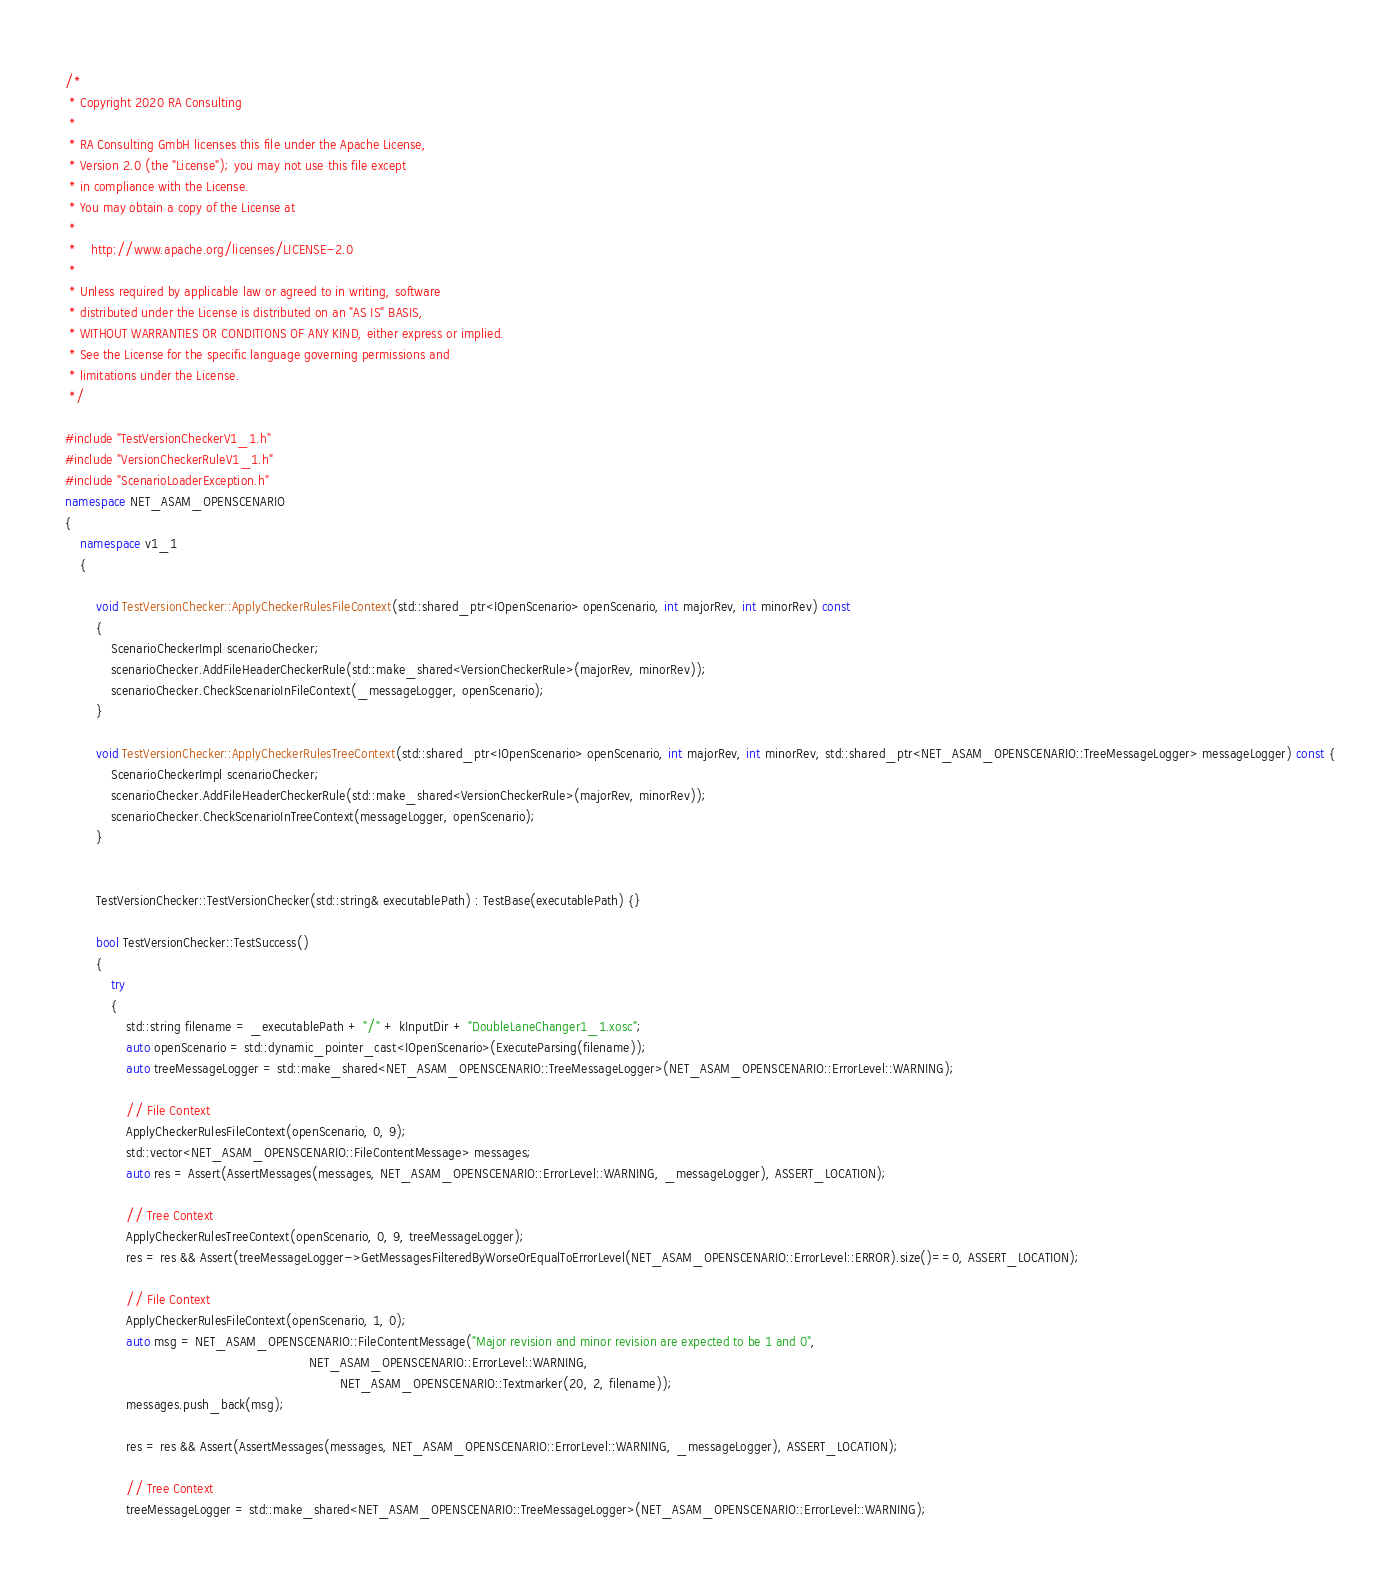<code> <loc_0><loc_0><loc_500><loc_500><_C++_>/*
 * Copyright 2020 RA Consulting
 *
 * RA Consulting GmbH licenses this file under the Apache License,
 * Version 2.0 (the "License"); you may not use this file except
 * in compliance with the License.
 * You may obtain a copy of the License at
 *
 *    http://www.apache.org/licenses/LICENSE-2.0
 *
 * Unless required by applicable law or agreed to in writing, software
 * distributed under the License is distributed on an "AS IS" BASIS,
 * WITHOUT WARRANTIES OR CONDITIONS OF ANY KIND, either express or implied.
 * See the License for the specific language governing permissions and
 * limitations under the License.
 */

#include "TestVersionCheckerV1_1.h"
#include "VersionCheckerRuleV1_1.h"
#include "ScenarioLoaderException.h"
namespace NET_ASAM_OPENSCENARIO
{
    namespace v1_1
	{

		void TestVersionChecker::ApplyCheckerRulesFileContext(std::shared_ptr<IOpenScenario> openScenario, int majorRev, int minorRev) const
		{
			ScenarioCheckerImpl scenarioChecker;
			scenarioChecker.AddFileHeaderCheckerRule(std::make_shared<VersionCheckerRule>(majorRev, minorRev));
			scenarioChecker.CheckScenarioInFileContext(_messageLogger, openScenario);
		}

		void TestVersionChecker::ApplyCheckerRulesTreeContext(std::shared_ptr<IOpenScenario> openScenario, int majorRev, int minorRev, std::shared_ptr<NET_ASAM_OPENSCENARIO::TreeMessageLogger> messageLogger) const {
			ScenarioCheckerImpl scenarioChecker;
			scenarioChecker.AddFileHeaderCheckerRule(std::make_shared<VersionCheckerRule>(majorRev, minorRev));
			scenarioChecker.CheckScenarioInTreeContext(messageLogger, openScenario);
		}


		TestVersionChecker::TestVersionChecker(std::string& executablePath) : TestBase(executablePath) {}

		bool TestVersionChecker::TestSuccess()
		{
			try 
			{
				std::string filename = _executablePath + "/" + kInputDir + "DoubleLaneChanger1_1.xosc";
				auto openScenario = std::dynamic_pointer_cast<IOpenScenario>(ExecuteParsing(filename));
				auto treeMessageLogger = std::make_shared<NET_ASAM_OPENSCENARIO::TreeMessageLogger>(NET_ASAM_OPENSCENARIO::ErrorLevel::WARNING);

				// File Context
				ApplyCheckerRulesFileContext(openScenario, 0, 9);
				std::vector<NET_ASAM_OPENSCENARIO::FileContentMessage> messages;
				auto res = Assert(AssertMessages(messages, NET_ASAM_OPENSCENARIO::ErrorLevel::WARNING, _messageLogger), ASSERT_LOCATION);

				// Tree Context
				ApplyCheckerRulesTreeContext(openScenario, 0, 9, treeMessageLogger);
				res = res && Assert(treeMessageLogger->GetMessagesFilteredByWorseOrEqualToErrorLevel(NET_ASAM_OPENSCENARIO::ErrorLevel::ERROR).size()==0, ASSERT_LOCATION);

				// File Context
				ApplyCheckerRulesFileContext(openScenario, 1, 0);
				auto msg = NET_ASAM_OPENSCENARIO::FileContentMessage("Major revision and minor revision are expected to be 1 and 0",
																NET_ASAM_OPENSCENARIO::ErrorLevel::WARNING,
																		NET_ASAM_OPENSCENARIO::Textmarker(20, 2, filename));
				messages.push_back(msg);

				res = res && Assert(AssertMessages(messages, NET_ASAM_OPENSCENARIO::ErrorLevel::WARNING, _messageLogger), ASSERT_LOCATION);

				// Tree Context
				treeMessageLogger = std::make_shared<NET_ASAM_OPENSCENARIO::TreeMessageLogger>(NET_ASAM_OPENSCENARIO::ErrorLevel::WARNING);</code> 